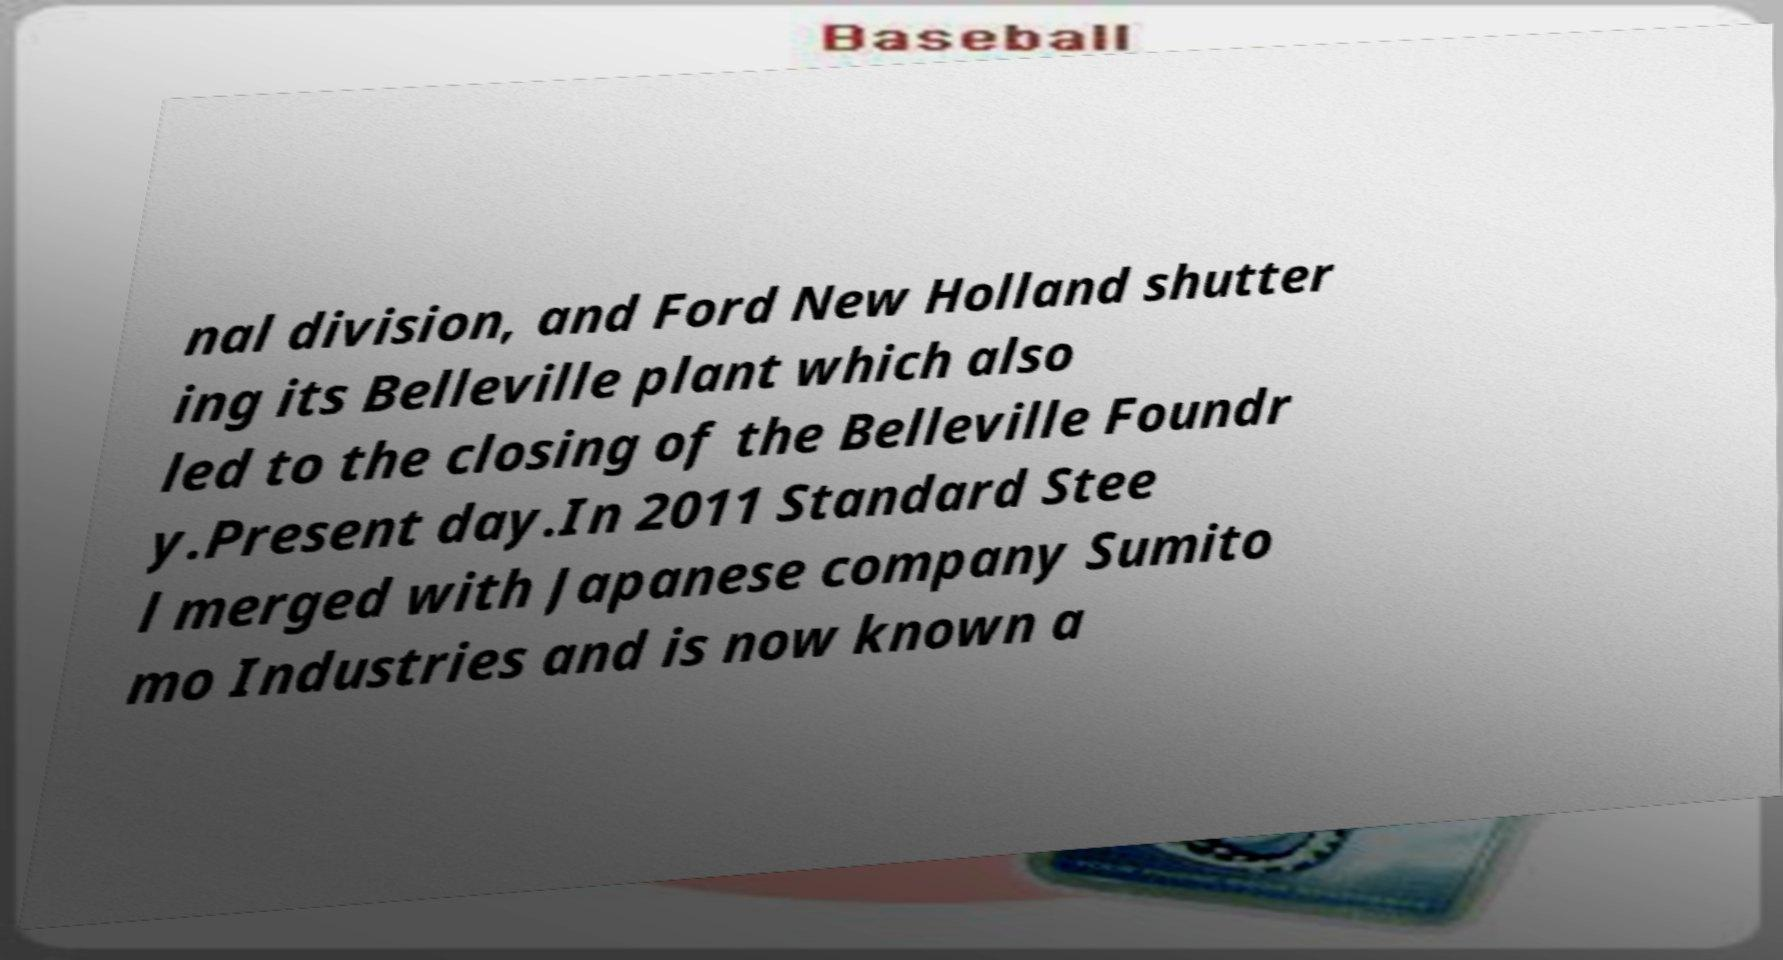Can you accurately transcribe the text from the provided image for me? nal division, and Ford New Holland shutter ing its Belleville plant which also led to the closing of the Belleville Foundr y.Present day.In 2011 Standard Stee l merged with Japanese company Sumito mo Industries and is now known a 